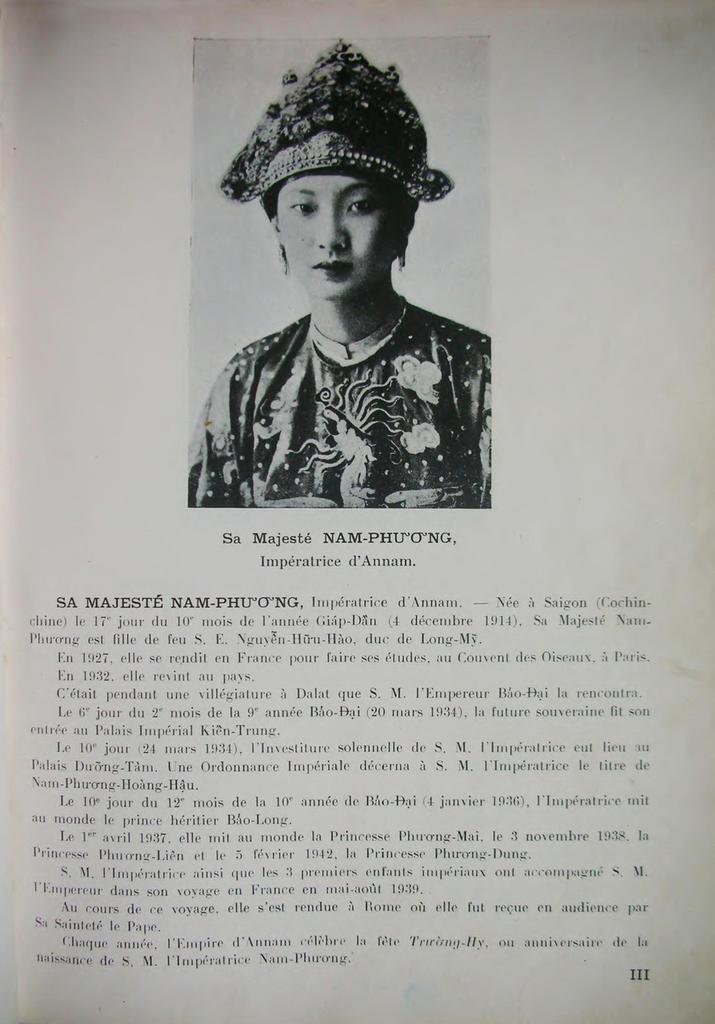In one or two sentences, can you explain what this image depicts? In this picture we can see a paper, in the paper we can find a woman. 